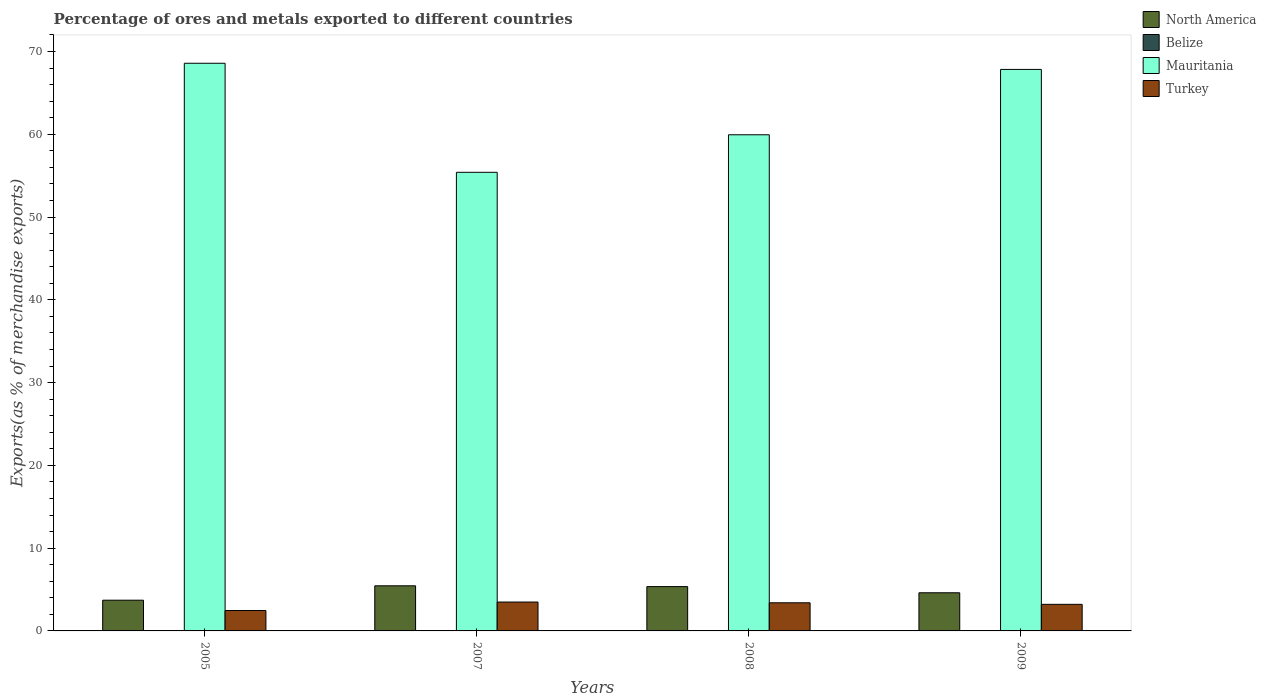How many different coloured bars are there?
Give a very brief answer. 4. Are the number of bars per tick equal to the number of legend labels?
Your answer should be compact. Yes. Are the number of bars on each tick of the X-axis equal?
Your answer should be very brief. Yes. How many bars are there on the 3rd tick from the right?
Give a very brief answer. 4. What is the percentage of exports to different countries in North America in 2009?
Make the answer very short. 4.61. Across all years, what is the maximum percentage of exports to different countries in Belize?
Your response must be concise. 0.02. Across all years, what is the minimum percentage of exports to different countries in Belize?
Ensure brevity in your answer.  0. In which year was the percentage of exports to different countries in Turkey maximum?
Your answer should be very brief. 2007. What is the total percentage of exports to different countries in Mauritania in the graph?
Make the answer very short. 251.77. What is the difference between the percentage of exports to different countries in North America in 2005 and that in 2008?
Ensure brevity in your answer.  -1.64. What is the difference between the percentage of exports to different countries in Belize in 2005 and the percentage of exports to different countries in Mauritania in 2009?
Provide a short and direct response. -67.82. What is the average percentage of exports to different countries in Turkey per year?
Offer a very short reply. 3.14. In the year 2005, what is the difference between the percentage of exports to different countries in North America and percentage of exports to different countries in Turkey?
Your answer should be very brief. 1.25. In how many years, is the percentage of exports to different countries in North America greater than 32 %?
Provide a succinct answer. 0. What is the ratio of the percentage of exports to different countries in North America in 2005 to that in 2009?
Your response must be concise. 0.81. Is the percentage of exports to different countries in Belize in 2008 less than that in 2009?
Your answer should be very brief. No. What is the difference between the highest and the second highest percentage of exports to different countries in North America?
Make the answer very short. 0.1. What is the difference between the highest and the lowest percentage of exports to different countries in Belize?
Keep it short and to the point. 0.02. Is it the case that in every year, the sum of the percentage of exports to different countries in North America and percentage of exports to different countries in Turkey is greater than the sum of percentage of exports to different countries in Mauritania and percentage of exports to different countries in Belize?
Your response must be concise. No. What does the 2nd bar from the left in 2005 represents?
Your answer should be compact. Belize. What does the 2nd bar from the right in 2005 represents?
Give a very brief answer. Mauritania. Is it the case that in every year, the sum of the percentage of exports to different countries in Mauritania and percentage of exports to different countries in Belize is greater than the percentage of exports to different countries in Turkey?
Make the answer very short. Yes. What is the difference between two consecutive major ticks on the Y-axis?
Give a very brief answer. 10. Are the values on the major ticks of Y-axis written in scientific E-notation?
Provide a short and direct response. No. Where does the legend appear in the graph?
Keep it short and to the point. Top right. How are the legend labels stacked?
Keep it short and to the point. Vertical. What is the title of the graph?
Offer a terse response. Percentage of ores and metals exported to different countries. What is the label or title of the X-axis?
Make the answer very short. Years. What is the label or title of the Y-axis?
Your answer should be compact. Exports(as % of merchandise exports). What is the Exports(as % of merchandise exports) of North America in 2005?
Your answer should be compact. 3.71. What is the Exports(as % of merchandise exports) of Belize in 2005?
Keep it short and to the point. 0.02. What is the Exports(as % of merchandise exports) in Mauritania in 2005?
Provide a short and direct response. 68.58. What is the Exports(as % of merchandise exports) in Turkey in 2005?
Provide a short and direct response. 2.46. What is the Exports(as % of merchandise exports) in North America in 2007?
Your answer should be compact. 5.45. What is the Exports(as % of merchandise exports) in Belize in 2007?
Your answer should be very brief. 0. What is the Exports(as % of merchandise exports) of Mauritania in 2007?
Your response must be concise. 55.41. What is the Exports(as % of merchandise exports) in Turkey in 2007?
Your answer should be very brief. 3.49. What is the Exports(as % of merchandise exports) in North America in 2008?
Offer a terse response. 5.35. What is the Exports(as % of merchandise exports) of Belize in 2008?
Your response must be concise. 0. What is the Exports(as % of merchandise exports) of Mauritania in 2008?
Offer a terse response. 59.94. What is the Exports(as % of merchandise exports) in Turkey in 2008?
Provide a succinct answer. 3.4. What is the Exports(as % of merchandise exports) of North America in 2009?
Your response must be concise. 4.61. What is the Exports(as % of merchandise exports) of Belize in 2009?
Provide a succinct answer. 0. What is the Exports(as % of merchandise exports) of Mauritania in 2009?
Ensure brevity in your answer.  67.84. What is the Exports(as % of merchandise exports) of Turkey in 2009?
Keep it short and to the point. 3.21. Across all years, what is the maximum Exports(as % of merchandise exports) in North America?
Provide a succinct answer. 5.45. Across all years, what is the maximum Exports(as % of merchandise exports) in Belize?
Offer a very short reply. 0.02. Across all years, what is the maximum Exports(as % of merchandise exports) in Mauritania?
Provide a short and direct response. 68.58. Across all years, what is the maximum Exports(as % of merchandise exports) in Turkey?
Your answer should be very brief. 3.49. Across all years, what is the minimum Exports(as % of merchandise exports) of North America?
Provide a short and direct response. 3.71. Across all years, what is the minimum Exports(as % of merchandise exports) of Belize?
Your response must be concise. 0. Across all years, what is the minimum Exports(as % of merchandise exports) of Mauritania?
Offer a terse response. 55.41. Across all years, what is the minimum Exports(as % of merchandise exports) in Turkey?
Offer a very short reply. 2.46. What is the total Exports(as % of merchandise exports) in North America in the graph?
Ensure brevity in your answer.  19.13. What is the total Exports(as % of merchandise exports) of Belize in the graph?
Ensure brevity in your answer.  0.03. What is the total Exports(as % of merchandise exports) in Mauritania in the graph?
Give a very brief answer. 251.77. What is the total Exports(as % of merchandise exports) of Turkey in the graph?
Provide a short and direct response. 12.56. What is the difference between the Exports(as % of merchandise exports) in North America in 2005 and that in 2007?
Offer a terse response. -1.74. What is the difference between the Exports(as % of merchandise exports) in Belize in 2005 and that in 2007?
Provide a succinct answer. 0.02. What is the difference between the Exports(as % of merchandise exports) in Mauritania in 2005 and that in 2007?
Your answer should be very brief. 13.17. What is the difference between the Exports(as % of merchandise exports) of Turkey in 2005 and that in 2007?
Make the answer very short. -1.03. What is the difference between the Exports(as % of merchandise exports) in North America in 2005 and that in 2008?
Provide a succinct answer. -1.64. What is the difference between the Exports(as % of merchandise exports) in Belize in 2005 and that in 2008?
Provide a short and direct response. 0.02. What is the difference between the Exports(as % of merchandise exports) in Mauritania in 2005 and that in 2008?
Your response must be concise. 8.64. What is the difference between the Exports(as % of merchandise exports) in Turkey in 2005 and that in 2008?
Provide a short and direct response. -0.94. What is the difference between the Exports(as % of merchandise exports) of North America in 2005 and that in 2009?
Your answer should be very brief. -0.9. What is the difference between the Exports(as % of merchandise exports) of Belize in 2005 and that in 2009?
Provide a succinct answer. 0.02. What is the difference between the Exports(as % of merchandise exports) of Mauritania in 2005 and that in 2009?
Give a very brief answer. 0.74. What is the difference between the Exports(as % of merchandise exports) of Turkey in 2005 and that in 2009?
Make the answer very short. -0.75. What is the difference between the Exports(as % of merchandise exports) of North America in 2007 and that in 2008?
Offer a terse response. 0.1. What is the difference between the Exports(as % of merchandise exports) in Belize in 2007 and that in 2008?
Ensure brevity in your answer.  -0. What is the difference between the Exports(as % of merchandise exports) of Mauritania in 2007 and that in 2008?
Provide a succinct answer. -4.53. What is the difference between the Exports(as % of merchandise exports) in Turkey in 2007 and that in 2008?
Keep it short and to the point. 0.09. What is the difference between the Exports(as % of merchandise exports) in North America in 2007 and that in 2009?
Make the answer very short. 0.84. What is the difference between the Exports(as % of merchandise exports) in Belize in 2007 and that in 2009?
Your answer should be very brief. 0. What is the difference between the Exports(as % of merchandise exports) of Mauritania in 2007 and that in 2009?
Your response must be concise. -12.43. What is the difference between the Exports(as % of merchandise exports) of Turkey in 2007 and that in 2009?
Provide a short and direct response. 0.28. What is the difference between the Exports(as % of merchandise exports) of North America in 2008 and that in 2009?
Offer a terse response. 0.75. What is the difference between the Exports(as % of merchandise exports) of Belize in 2008 and that in 2009?
Offer a terse response. 0. What is the difference between the Exports(as % of merchandise exports) of Mauritania in 2008 and that in 2009?
Your response must be concise. -7.9. What is the difference between the Exports(as % of merchandise exports) of Turkey in 2008 and that in 2009?
Your answer should be compact. 0.19. What is the difference between the Exports(as % of merchandise exports) in North America in 2005 and the Exports(as % of merchandise exports) in Belize in 2007?
Provide a succinct answer. 3.71. What is the difference between the Exports(as % of merchandise exports) in North America in 2005 and the Exports(as % of merchandise exports) in Mauritania in 2007?
Provide a short and direct response. -51.7. What is the difference between the Exports(as % of merchandise exports) in North America in 2005 and the Exports(as % of merchandise exports) in Turkey in 2007?
Provide a succinct answer. 0.22. What is the difference between the Exports(as % of merchandise exports) of Belize in 2005 and the Exports(as % of merchandise exports) of Mauritania in 2007?
Make the answer very short. -55.39. What is the difference between the Exports(as % of merchandise exports) in Belize in 2005 and the Exports(as % of merchandise exports) in Turkey in 2007?
Ensure brevity in your answer.  -3.47. What is the difference between the Exports(as % of merchandise exports) in Mauritania in 2005 and the Exports(as % of merchandise exports) in Turkey in 2007?
Offer a very short reply. 65.09. What is the difference between the Exports(as % of merchandise exports) in North America in 2005 and the Exports(as % of merchandise exports) in Belize in 2008?
Give a very brief answer. 3.71. What is the difference between the Exports(as % of merchandise exports) in North America in 2005 and the Exports(as % of merchandise exports) in Mauritania in 2008?
Give a very brief answer. -56.23. What is the difference between the Exports(as % of merchandise exports) of North America in 2005 and the Exports(as % of merchandise exports) of Turkey in 2008?
Give a very brief answer. 0.31. What is the difference between the Exports(as % of merchandise exports) in Belize in 2005 and the Exports(as % of merchandise exports) in Mauritania in 2008?
Your answer should be compact. -59.92. What is the difference between the Exports(as % of merchandise exports) in Belize in 2005 and the Exports(as % of merchandise exports) in Turkey in 2008?
Make the answer very short. -3.38. What is the difference between the Exports(as % of merchandise exports) of Mauritania in 2005 and the Exports(as % of merchandise exports) of Turkey in 2008?
Provide a succinct answer. 65.18. What is the difference between the Exports(as % of merchandise exports) in North America in 2005 and the Exports(as % of merchandise exports) in Belize in 2009?
Offer a terse response. 3.71. What is the difference between the Exports(as % of merchandise exports) in North America in 2005 and the Exports(as % of merchandise exports) in Mauritania in 2009?
Offer a very short reply. -64.13. What is the difference between the Exports(as % of merchandise exports) in North America in 2005 and the Exports(as % of merchandise exports) in Turkey in 2009?
Provide a succinct answer. 0.5. What is the difference between the Exports(as % of merchandise exports) in Belize in 2005 and the Exports(as % of merchandise exports) in Mauritania in 2009?
Provide a succinct answer. -67.82. What is the difference between the Exports(as % of merchandise exports) in Belize in 2005 and the Exports(as % of merchandise exports) in Turkey in 2009?
Keep it short and to the point. -3.19. What is the difference between the Exports(as % of merchandise exports) in Mauritania in 2005 and the Exports(as % of merchandise exports) in Turkey in 2009?
Offer a very short reply. 65.37. What is the difference between the Exports(as % of merchandise exports) of North America in 2007 and the Exports(as % of merchandise exports) of Belize in 2008?
Provide a succinct answer. 5.45. What is the difference between the Exports(as % of merchandise exports) in North America in 2007 and the Exports(as % of merchandise exports) in Mauritania in 2008?
Offer a very short reply. -54.49. What is the difference between the Exports(as % of merchandise exports) in North America in 2007 and the Exports(as % of merchandise exports) in Turkey in 2008?
Your answer should be compact. 2.05. What is the difference between the Exports(as % of merchandise exports) in Belize in 2007 and the Exports(as % of merchandise exports) in Mauritania in 2008?
Provide a short and direct response. -59.94. What is the difference between the Exports(as % of merchandise exports) of Belize in 2007 and the Exports(as % of merchandise exports) of Turkey in 2008?
Offer a very short reply. -3.4. What is the difference between the Exports(as % of merchandise exports) in Mauritania in 2007 and the Exports(as % of merchandise exports) in Turkey in 2008?
Your answer should be compact. 52.01. What is the difference between the Exports(as % of merchandise exports) in North America in 2007 and the Exports(as % of merchandise exports) in Belize in 2009?
Your response must be concise. 5.45. What is the difference between the Exports(as % of merchandise exports) in North America in 2007 and the Exports(as % of merchandise exports) in Mauritania in 2009?
Offer a terse response. -62.39. What is the difference between the Exports(as % of merchandise exports) in North America in 2007 and the Exports(as % of merchandise exports) in Turkey in 2009?
Keep it short and to the point. 2.24. What is the difference between the Exports(as % of merchandise exports) in Belize in 2007 and the Exports(as % of merchandise exports) in Mauritania in 2009?
Give a very brief answer. -67.84. What is the difference between the Exports(as % of merchandise exports) in Belize in 2007 and the Exports(as % of merchandise exports) in Turkey in 2009?
Make the answer very short. -3.21. What is the difference between the Exports(as % of merchandise exports) of Mauritania in 2007 and the Exports(as % of merchandise exports) of Turkey in 2009?
Keep it short and to the point. 52.2. What is the difference between the Exports(as % of merchandise exports) of North America in 2008 and the Exports(as % of merchandise exports) of Belize in 2009?
Your answer should be compact. 5.35. What is the difference between the Exports(as % of merchandise exports) in North America in 2008 and the Exports(as % of merchandise exports) in Mauritania in 2009?
Your answer should be compact. -62.48. What is the difference between the Exports(as % of merchandise exports) of North America in 2008 and the Exports(as % of merchandise exports) of Turkey in 2009?
Your response must be concise. 2.14. What is the difference between the Exports(as % of merchandise exports) of Belize in 2008 and the Exports(as % of merchandise exports) of Mauritania in 2009?
Make the answer very short. -67.83. What is the difference between the Exports(as % of merchandise exports) in Belize in 2008 and the Exports(as % of merchandise exports) in Turkey in 2009?
Offer a terse response. -3.21. What is the difference between the Exports(as % of merchandise exports) of Mauritania in 2008 and the Exports(as % of merchandise exports) of Turkey in 2009?
Your response must be concise. 56.73. What is the average Exports(as % of merchandise exports) in North America per year?
Your answer should be compact. 4.78. What is the average Exports(as % of merchandise exports) in Belize per year?
Your response must be concise. 0.01. What is the average Exports(as % of merchandise exports) of Mauritania per year?
Your answer should be compact. 62.94. What is the average Exports(as % of merchandise exports) of Turkey per year?
Your answer should be compact. 3.14. In the year 2005, what is the difference between the Exports(as % of merchandise exports) of North America and Exports(as % of merchandise exports) of Belize?
Your answer should be very brief. 3.69. In the year 2005, what is the difference between the Exports(as % of merchandise exports) in North America and Exports(as % of merchandise exports) in Mauritania?
Offer a terse response. -64.87. In the year 2005, what is the difference between the Exports(as % of merchandise exports) in North America and Exports(as % of merchandise exports) in Turkey?
Keep it short and to the point. 1.25. In the year 2005, what is the difference between the Exports(as % of merchandise exports) in Belize and Exports(as % of merchandise exports) in Mauritania?
Make the answer very short. -68.56. In the year 2005, what is the difference between the Exports(as % of merchandise exports) in Belize and Exports(as % of merchandise exports) in Turkey?
Keep it short and to the point. -2.44. In the year 2005, what is the difference between the Exports(as % of merchandise exports) in Mauritania and Exports(as % of merchandise exports) in Turkey?
Provide a succinct answer. 66.12. In the year 2007, what is the difference between the Exports(as % of merchandise exports) in North America and Exports(as % of merchandise exports) in Belize?
Your answer should be very brief. 5.45. In the year 2007, what is the difference between the Exports(as % of merchandise exports) of North America and Exports(as % of merchandise exports) of Mauritania?
Ensure brevity in your answer.  -49.96. In the year 2007, what is the difference between the Exports(as % of merchandise exports) of North America and Exports(as % of merchandise exports) of Turkey?
Provide a short and direct response. 1.96. In the year 2007, what is the difference between the Exports(as % of merchandise exports) in Belize and Exports(as % of merchandise exports) in Mauritania?
Your answer should be compact. -55.41. In the year 2007, what is the difference between the Exports(as % of merchandise exports) in Belize and Exports(as % of merchandise exports) in Turkey?
Offer a very short reply. -3.49. In the year 2007, what is the difference between the Exports(as % of merchandise exports) of Mauritania and Exports(as % of merchandise exports) of Turkey?
Your answer should be very brief. 51.92. In the year 2008, what is the difference between the Exports(as % of merchandise exports) in North America and Exports(as % of merchandise exports) in Belize?
Offer a very short reply. 5.35. In the year 2008, what is the difference between the Exports(as % of merchandise exports) of North America and Exports(as % of merchandise exports) of Mauritania?
Keep it short and to the point. -54.59. In the year 2008, what is the difference between the Exports(as % of merchandise exports) in North America and Exports(as % of merchandise exports) in Turkey?
Offer a terse response. 1.96. In the year 2008, what is the difference between the Exports(as % of merchandise exports) in Belize and Exports(as % of merchandise exports) in Mauritania?
Ensure brevity in your answer.  -59.94. In the year 2008, what is the difference between the Exports(as % of merchandise exports) of Belize and Exports(as % of merchandise exports) of Turkey?
Give a very brief answer. -3.39. In the year 2008, what is the difference between the Exports(as % of merchandise exports) in Mauritania and Exports(as % of merchandise exports) in Turkey?
Keep it short and to the point. 56.54. In the year 2009, what is the difference between the Exports(as % of merchandise exports) in North America and Exports(as % of merchandise exports) in Belize?
Provide a short and direct response. 4.61. In the year 2009, what is the difference between the Exports(as % of merchandise exports) in North America and Exports(as % of merchandise exports) in Mauritania?
Your response must be concise. -63.23. In the year 2009, what is the difference between the Exports(as % of merchandise exports) of North America and Exports(as % of merchandise exports) of Turkey?
Your answer should be very brief. 1.4. In the year 2009, what is the difference between the Exports(as % of merchandise exports) of Belize and Exports(as % of merchandise exports) of Mauritania?
Make the answer very short. -67.84. In the year 2009, what is the difference between the Exports(as % of merchandise exports) of Belize and Exports(as % of merchandise exports) of Turkey?
Keep it short and to the point. -3.21. In the year 2009, what is the difference between the Exports(as % of merchandise exports) in Mauritania and Exports(as % of merchandise exports) in Turkey?
Offer a very short reply. 64.63. What is the ratio of the Exports(as % of merchandise exports) in North America in 2005 to that in 2007?
Offer a very short reply. 0.68. What is the ratio of the Exports(as % of merchandise exports) of Belize in 2005 to that in 2007?
Give a very brief answer. 10.61. What is the ratio of the Exports(as % of merchandise exports) in Mauritania in 2005 to that in 2007?
Provide a short and direct response. 1.24. What is the ratio of the Exports(as % of merchandise exports) of Turkey in 2005 to that in 2007?
Your response must be concise. 0.71. What is the ratio of the Exports(as % of merchandise exports) in North America in 2005 to that in 2008?
Your answer should be very brief. 0.69. What is the ratio of the Exports(as % of merchandise exports) of Belize in 2005 to that in 2008?
Make the answer very short. 4.36. What is the ratio of the Exports(as % of merchandise exports) of Mauritania in 2005 to that in 2008?
Offer a terse response. 1.14. What is the ratio of the Exports(as % of merchandise exports) in Turkey in 2005 to that in 2008?
Give a very brief answer. 0.72. What is the ratio of the Exports(as % of merchandise exports) in North America in 2005 to that in 2009?
Your answer should be compact. 0.81. What is the ratio of the Exports(as % of merchandise exports) of Belize in 2005 to that in 2009?
Your answer should be compact. 47.26. What is the ratio of the Exports(as % of merchandise exports) in Mauritania in 2005 to that in 2009?
Offer a terse response. 1.01. What is the ratio of the Exports(as % of merchandise exports) of Turkey in 2005 to that in 2009?
Your response must be concise. 0.77. What is the ratio of the Exports(as % of merchandise exports) of North America in 2007 to that in 2008?
Offer a very short reply. 1.02. What is the ratio of the Exports(as % of merchandise exports) in Belize in 2007 to that in 2008?
Offer a very short reply. 0.41. What is the ratio of the Exports(as % of merchandise exports) in Mauritania in 2007 to that in 2008?
Keep it short and to the point. 0.92. What is the ratio of the Exports(as % of merchandise exports) of Turkey in 2007 to that in 2008?
Provide a short and direct response. 1.03. What is the ratio of the Exports(as % of merchandise exports) in North America in 2007 to that in 2009?
Provide a succinct answer. 1.18. What is the ratio of the Exports(as % of merchandise exports) in Belize in 2007 to that in 2009?
Your response must be concise. 4.46. What is the ratio of the Exports(as % of merchandise exports) of Mauritania in 2007 to that in 2009?
Offer a terse response. 0.82. What is the ratio of the Exports(as % of merchandise exports) of Turkey in 2007 to that in 2009?
Offer a very short reply. 1.09. What is the ratio of the Exports(as % of merchandise exports) of North America in 2008 to that in 2009?
Provide a succinct answer. 1.16. What is the ratio of the Exports(as % of merchandise exports) in Belize in 2008 to that in 2009?
Offer a terse response. 10.83. What is the ratio of the Exports(as % of merchandise exports) in Mauritania in 2008 to that in 2009?
Your response must be concise. 0.88. What is the ratio of the Exports(as % of merchandise exports) of Turkey in 2008 to that in 2009?
Give a very brief answer. 1.06. What is the difference between the highest and the second highest Exports(as % of merchandise exports) in North America?
Make the answer very short. 0.1. What is the difference between the highest and the second highest Exports(as % of merchandise exports) of Belize?
Keep it short and to the point. 0.02. What is the difference between the highest and the second highest Exports(as % of merchandise exports) in Mauritania?
Offer a terse response. 0.74. What is the difference between the highest and the second highest Exports(as % of merchandise exports) in Turkey?
Keep it short and to the point. 0.09. What is the difference between the highest and the lowest Exports(as % of merchandise exports) in North America?
Provide a short and direct response. 1.74. What is the difference between the highest and the lowest Exports(as % of merchandise exports) in Belize?
Ensure brevity in your answer.  0.02. What is the difference between the highest and the lowest Exports(as % of merchandise exports) in Mauritania?
Your answer should be compact. 13.17. What is the difference between the highest and the lowest Exports(as % of merchandise exports) of Turkey?
Keep it short and to the point. 1.03. 